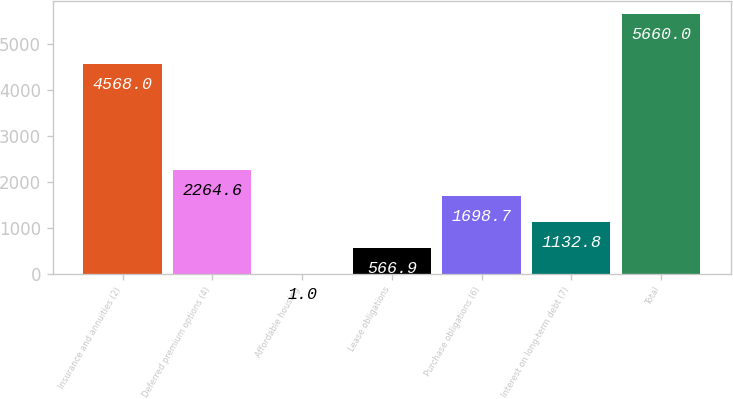Convert chart. <chart><loc_0><loc_0><loc_500><loc_500><bar_chart><fcel>Insurance and annuities (2)<fcel>Deferred premium options (4)<fcel>Affordable housing<fcel>Lease obligations<fcel>Purchase obligations (6)<fcel>Interest on long-term debt (7)<fcel>Total<nl><fcel>4568<fcel>2264.6<fcel>1<fcel>566.9<fcel>1698.7<fcel>1132.8<fcel>5660<nl></chart> 